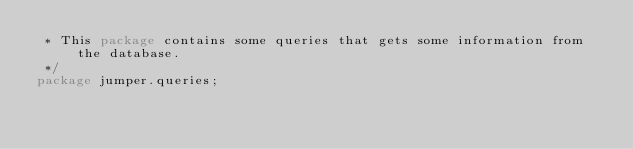Convert code to text. <code><loc_0><loc_0><loc_500><loc_500><_Java_> * This package contains some queries that gets some information from the database.
 */
package jumper.queries;</code> 